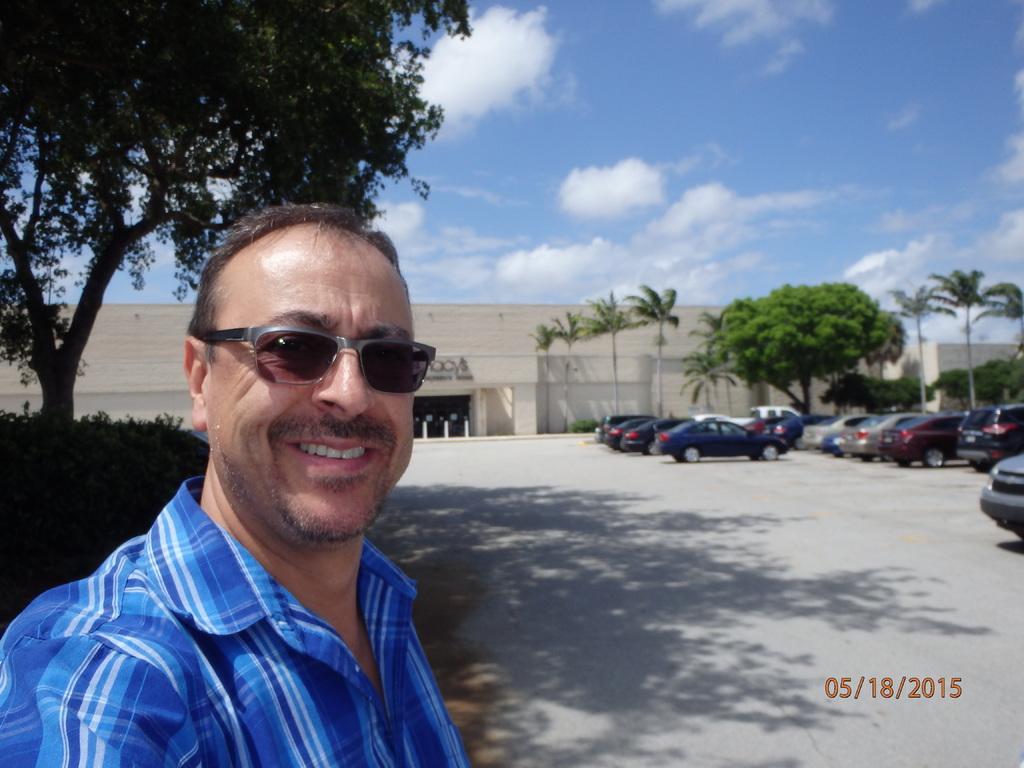Please provide a concise description of this image. In the picture I can see a man is standing and smiling. The man is wearing a blue color shirt and shades. In the background I can see buildings, vehicles, trees, poles and the sky. On the bottom right of the image I can see a watermark. 